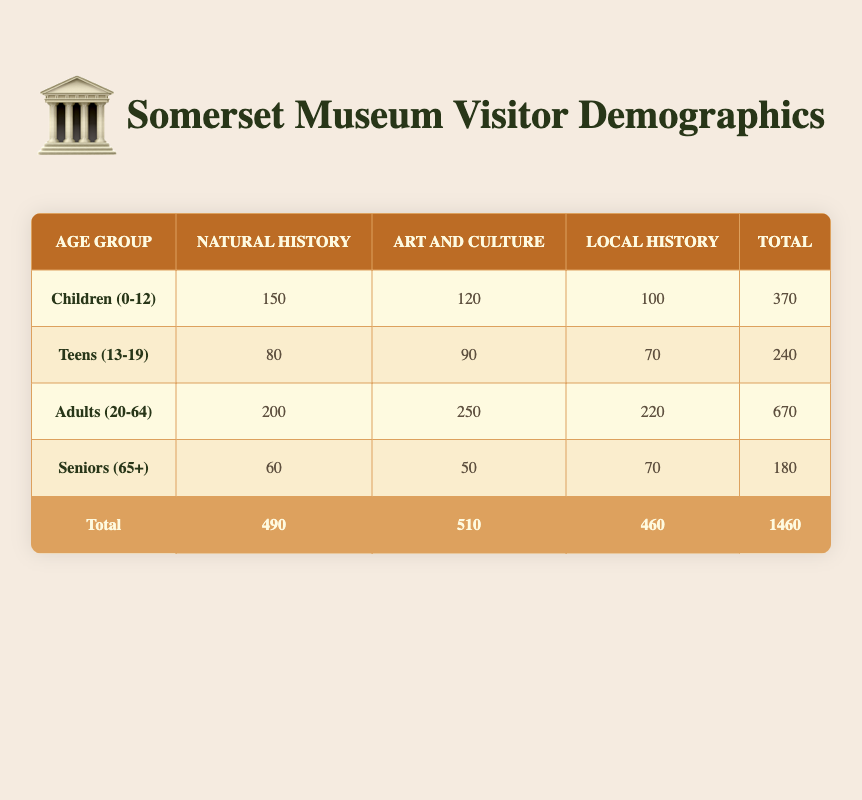What is the total number of visitors for the Art and Culture exhibit? To find the total number of visitors for the Art and Culture exhibit, I look at the corresponding column in the table. The values are 120 for Children, 90 for Teens, 250 for Adults, and 50 for Seniors. Adding these gives 120 + 90 + 250 + 50 = 510.
Answer: 510 Which age group has the highest number of visitors to the Natural History exhibit? In the Natural History column, the visitor counts are 150 for Children, 80 for Teens, 200 for Adults, and 60 for Seniors. The highest count is 200 for Adults.
Answer: Adults (20-64) What is the difference in the number of visitors between the Local History and Natural History exhibits combined? For the Local History total, I sum the visitors: 100 (Children) + 70 (Teens) + 220 (Adults) + 70 (Seniors) = 460. For the Natural History total: 150 (Children) + 80 (Teens) + 200 (Adults) + 60 (Seniors) = 490. The difference between these totals is 490 - 460 = 30.
Answer: 30 Are there more visitors in total for the Adults category compared to the combined total for Seniors and Children? The total for Adults is 670. For Seniors, the total is 180 and for Children, it's 370. Combined, that's 180 + 370 = 550. Since 670 > 550, the statement is true.
Answer: Yes What is the average number of visitors per age group for the Art and Culture exhibit? First, I find the total visitors for each age group: 120 (Children) + 90 (Teens) + 250 (Adults) + 50 (Seniors) = 510. Since there are 4 age groups, I calculate the average by dividing the total by the number of age groups: 510 / 4 = 127.5.
Answer: 127.5 What percentage of total visitors were Seniors for the Local History exhibit? The total number of visitors for the Local History exhibit is 460. The number of Seniors was 70. To find the percentage, I calculate (70 / 460) * 100, which equals approximately 15.2%.
Answer: 15.2% Is it true or false that Teens had more visitors than Seniors overall? To check this, I sum the total visitors for Teens: 240 (combining all exhibit types) and for Seniors: 180. Since 240 > 180, the statement is true.
Answer: Yes Which exhibit had the highest engagement from the Adults age group? Examining the Adults row: Natural History has 200, Art and Culture has 250, and Local History has 220. The highest engagement is 250 for the Art and Culture exhibit.
Answer: Art and Culture 